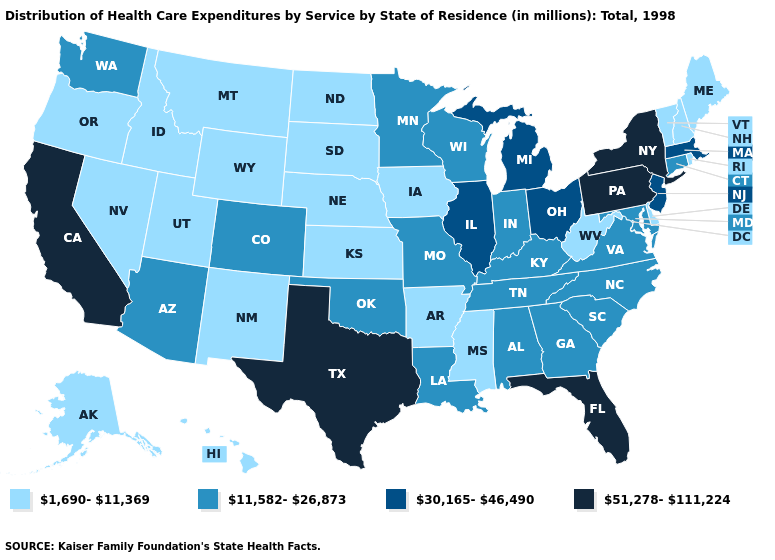Which states have the highest value in the USA?
Keep it brief. California, Florida, New York, Pennsylvania, Texas. Name the states that have a value in the range 51,278-111,224?
Quick response, please. California, Florida, New York, Pennsylvania, Texas. Name the states that have a value in the range 51,278-111,224?
Concise answer only. California, Florida, New York, Pennsylvania, Texas. What is the value of Vermont?
Answer briefly. 1,690-11,369. Does California have the lowest value in the USA?
Write a very short answer. No. What is the value of Nebraska?
Give a very brief answer. 1,690-11,369. What is the value of Michigan?
Answer briefly. 30,165-46,490. Among the states that border Virginia , does West Virginia have the highest value?
Short answer required. No. Which states have the highest value in the USA?
Quick response, please. California, Florida, New York, Pennsylvania, Texas. What is the lowest value in states that border New York?
Concise answer only. 1,690-11,369. Name the states that have a value in the range 1,690-11,369?
Give a very brief answer. Alaska, Arkansas, Delaware, Hawaii, Idaho, Iowa, Kansas, Maine, Mississippi, Montana, Nebraska, Nevada, New Hampshire, New Mexico, North Dakota, Oregon, Rhode Island, South Dakota, Utah, Vermont, West Virginia, Wyoming. Which states have the lowest value in the USA?
Keep it brief. Alaska, Arkansas, Delaware, Hawaii, Idaho, Iowa, Kansas, Maine, Mississippi, Montana, Nebraska, Nevada, New Hampshire, New Mexico, North Dakota, Oregon, Rhode Island, South Dakota, Utah, Vermont, West Virginia, Wyoming. What is the value of Wisconsin?
Write a very short answer. 11,582-26,873. 